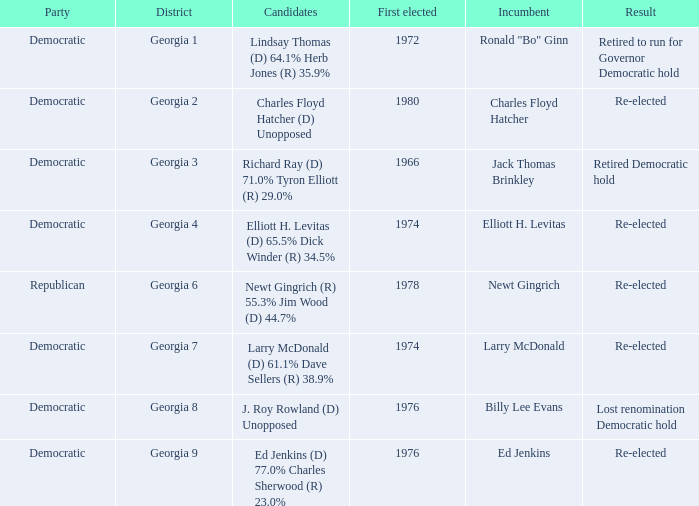Name the districk for larry mcdonald Georgia 7. 